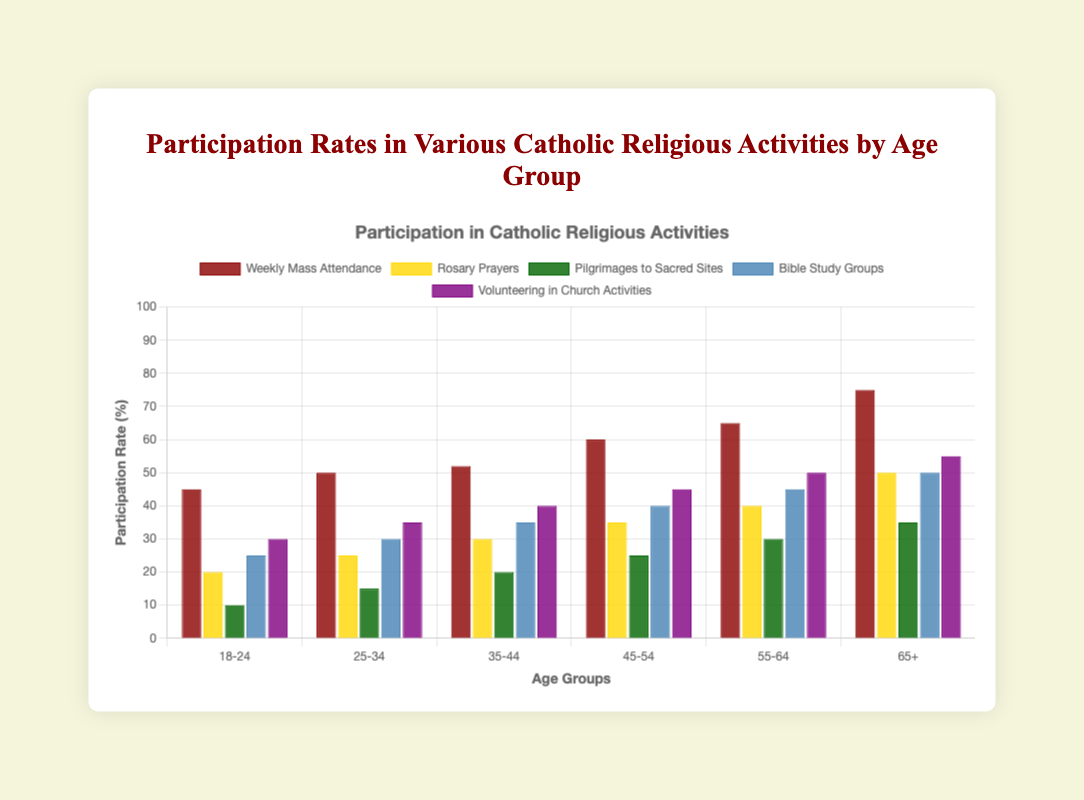What's the participation rate in Weekly Mass Attendance for age group 65+? The bar representing Weekly Mass Attendance for the 65+ age group reaches a height indicating 75%.
Answer: 75% Which activity has the lowest participation rate for the 18-24 age group? By examining the shortest bar for the 18-24 age group, Pilgrimages to Sacred Sites has the lowest participation rate at 10%.
Answer: Pilgrimages to Sacred Sites What is the difference in participation rates of Bible Study Groups between age groups 18-24 and 65+? The participation rates are 25% for 18-24 and 50% for 65+. The difference is 50% - 25% = 25%.
Answer: 25% Compare the participation rates of Rosary Prayers and Volunteering in Church Activities for the 55-64 age group. Which one is higher? The bar for Rosary Prayers shows 40%, while the bar for Volunteering in Church Activities shows 50%. Thus, Volunteering in Church Activities is higher.
Answer: Volunteering in Church Activities What is the average participation rate for Pilgrimages to Sacred Sites across all age groups? Summing the participation rates for each age group (10 + 15 + 20 + 25 + 30 + 35) = 135, and dividing by the number of age groups (6) gives 135 / 6 = 22.5%.
Answer: 22.5% What is the sum of participation rates for Weekly Mass Attendance and Rosary Prayers for the 35-44 age group? The participation rates are 52% for Weekly Mass Attendance and 30% for Rosary Prayers. Adding these gives 52% + 30% = 82%.
Answer: 82% Which activity shows the highest increase in participation rates from the 18-24 to the 65+ age group? By calculating the differences: 
- Weekly Mass Attendance: 75% - 45% = 30%
- Rosary Prayers: 50% - 20% = 30%
- Pilgrimages to Sacred Sites: 35% - 10% = 25%
- Bible Study Groups: 50% - 25% = 25%
- Volunteering: 55% - 30% = 25%
Weekly Mass Attendance and Rosary Prayers both show the highest increase of 30%.
Answer: Weekly Mass Attendance, Rosary Prayers Between the age groups 25-34 and 55-64, in which age group is the participation in Volunteering in Church Activities higher? The bar for 25-34 indicates 35%, while the bar for 55-64 indicates 50%. Hence, it’s higher in the 55-64 age group.
Answer: 55-64 Which activity consistently increases in participation rate with each consecutive age group? Examining each activity, Weekly Mass Attendance, Rosary Prayers, Pilgrimages to Sacred Sites, Bible Study Groups, and Volunteering in Church Activities each show an increasing trend across all age groups.
Answer: All activities 